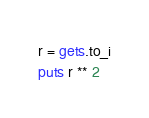Convert code to text. <code><loc_0><loc_0><loc_500><loc_500><_Ruby_>r = gets.to_i
puts r ** 2</code> 